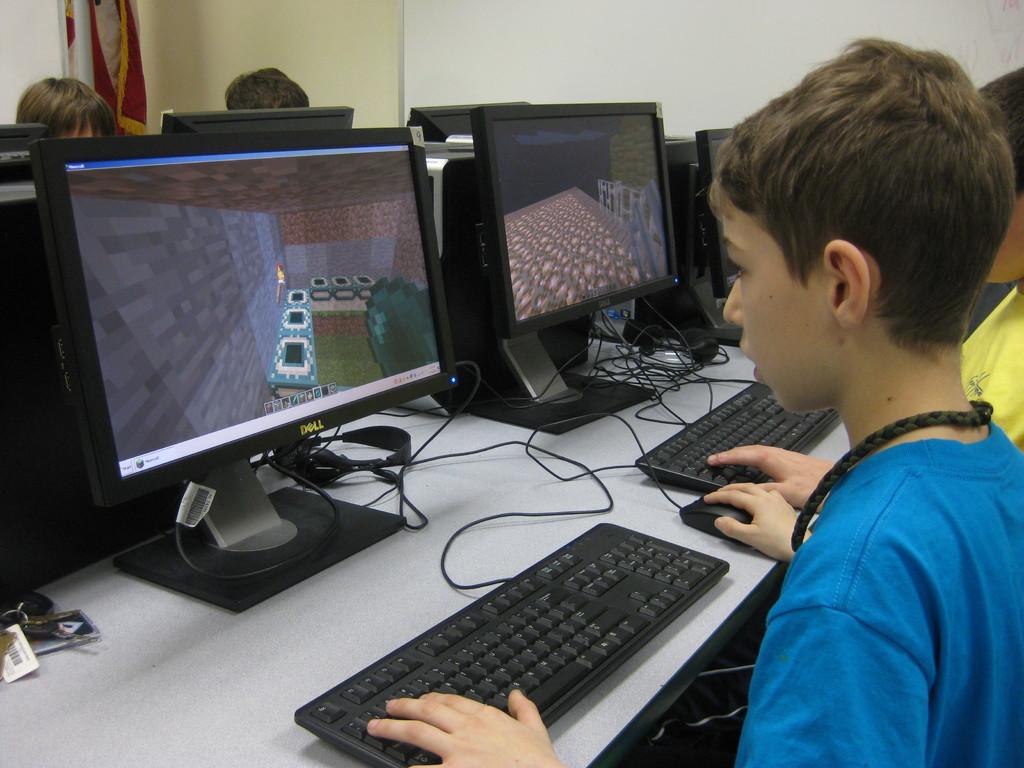What brand of monitor is that on the left?
Offer a very short reply. Dell. 